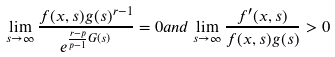Convert formula to latex. <formula><loc_0><loc_0><loc_500><loc_500>\lim _ { s \to \infty } \frac { f ( x , s ) g ( s ) ^ { r - 1 } } { e ^ { \frac { r - p } { p - 1 } G ( s ) } } = 0 a n d \lim _ { s \to \infty } \frac { f ^ { \prime } ( x , s ) } { f ( x , s ) g ( s ) } > 0</formula> 